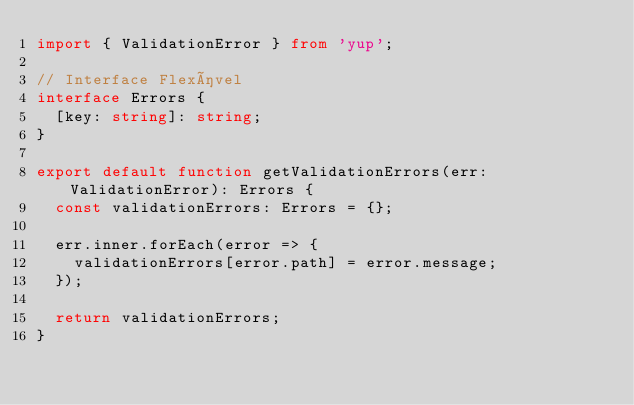Convert code to text. <code><loc_0><loc_0><loc_500><loc_500><_TypeScript_>import { ValidationError } from 'yup';

// Interface Flexível
interface Errors {
  [key: string]: string;
}

export default function getValidationErrors(err: ValidationError): Errors {
  const validationErrors: Errors = {};

  err.inner.forEach(error => {
    validationErrors[error.path] = error.message;
  });

  return validationErrors;
}
</code> 